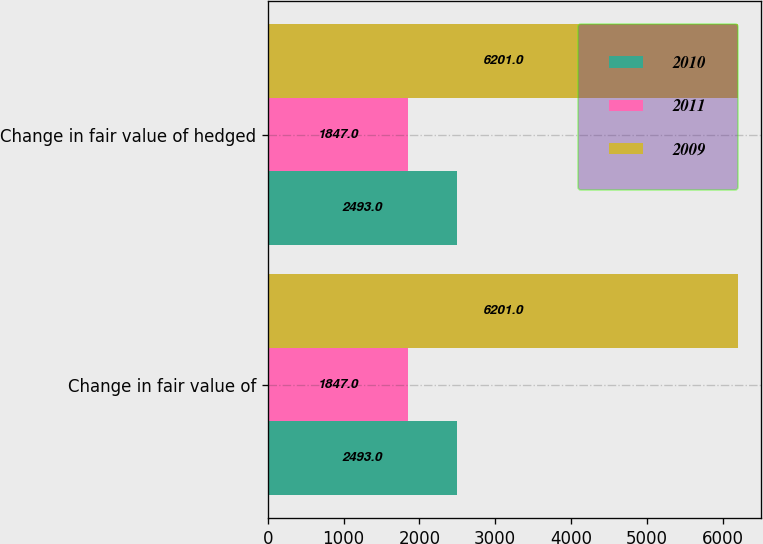<chart> <loc_0><loc_0><loc_500><loc_500><stacked_bar_chart><ecel><fcel>Change in fair value of<fcel>Change in fair value of hedged<nl><fcel>2010<fcel>2493<fcel>2493<nl><fcel>2011<fcel>1847<fcel>1847<nl><fcel>2009<fcel>6201<fcel>6201<nl></chart> 